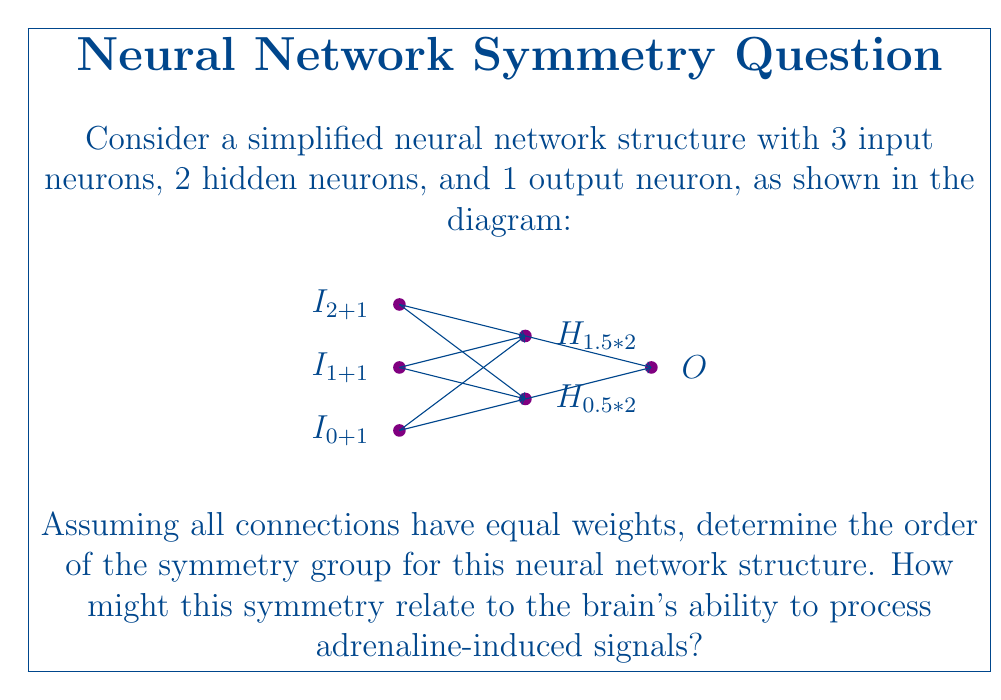Solve this math problem. To solve this problem, we need to analyze the symmetries of the neural network structure:

1) First, observe that the input layer has 3 neurons ($I_1$, $I_2$, $I_3$). Since all connections have equal weights, these neurons can be permuted without changing the network's function. This gives us a symmetry of order 3! = 6.

2) The hidden layer has 2 neurons ($H_1$, $H_2$). These can be swapped, giving an additional symmetry of order 2! = 2.

3) The output layer has only 1 neuron, so it doesn't contribute to the symmetry.

4) The total symmetry group is the direct product of these individual symmetries:

   $$ |G| = 6 \times 2 = 12 $$

Therefore, the symmetry group of this neural network has order 12.

Relating this to adrenaline processing in the brain:

5) The symmetry in the input layer (order 6) could represent the brain's ability to process adrenaline signals from multiple sources equivalently. This might correspond to different physiological responses triggered by adrenaline (e.g., increased heart rate, dilated pupils, heightened awareness).

6) The symmetry in the hidden layer (order 2) could represent the brain's ability to process these signals through parallel pathways, potentially allowing for redundancy and robustness in adrenaline response processing.

7) The high degree of symmetry (order 12) suggests that the brain's neural networks for processing adrenaline-induced signals might be highly flexible and adaptable, allowing for efficient processing of these critical survival-related signals from various inputs and through multiple pathways.
Answer: 12 